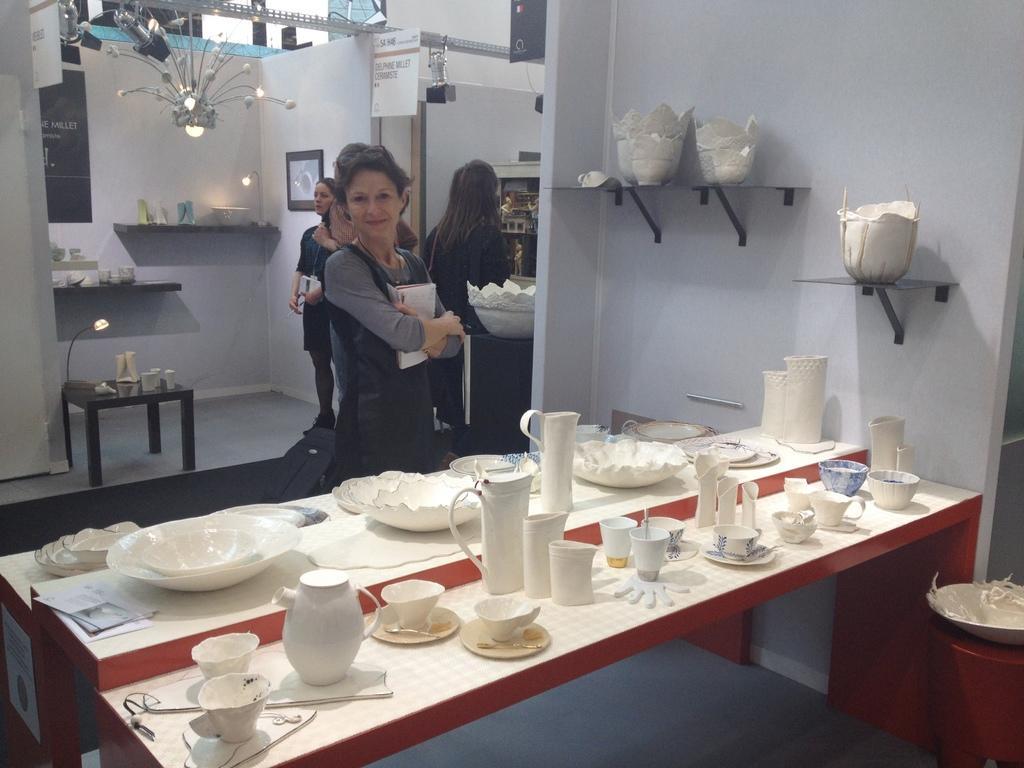In one or two sentences, can you explain what this image depicts? In this image i can see group of people standing and i can see a table on which there are many ceramic objects. In the background i can see a wall, a mirror, a table and a chandelier. 